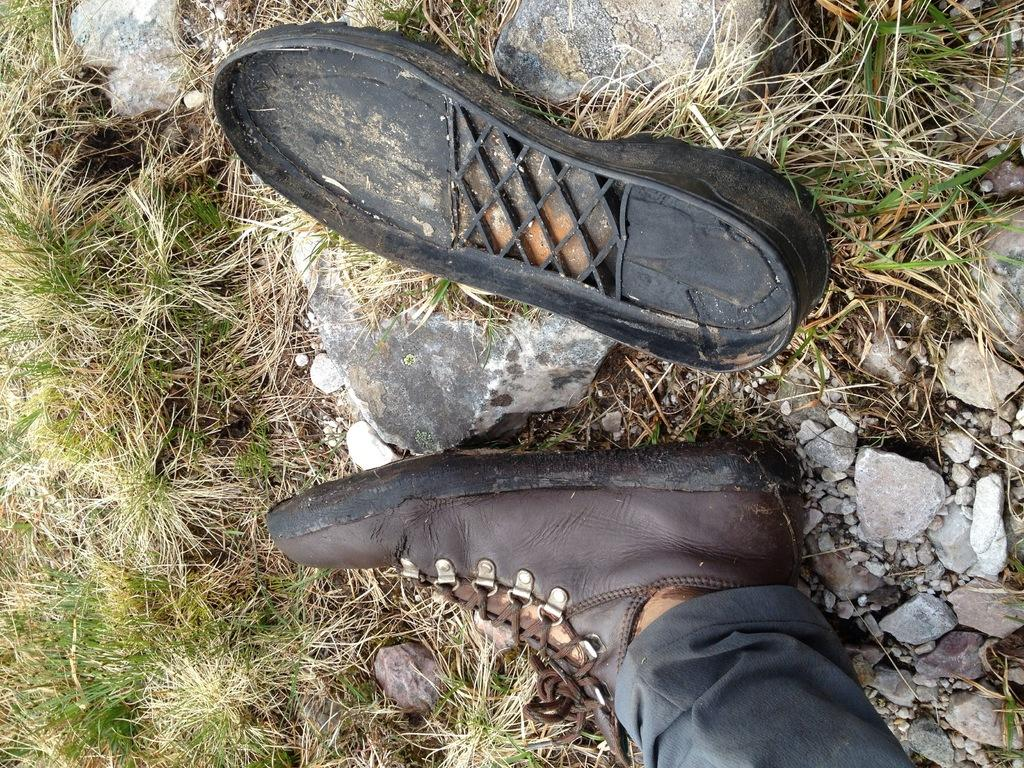What is the main subject in the foreground of the image? There is a leg visible in the foreground of the image. Where is the leg located? The leg is on the grass. What other objects can be seen in the image? There are stones in the image. What part of a shoe can be seen at the top of the image? The sole of a shoe is visible at the top of the image. What type of yam is being prepared by the person's aunt in the image? There is no person, aunt, or yam present in the image; it only features a leg on the grass and stones. 